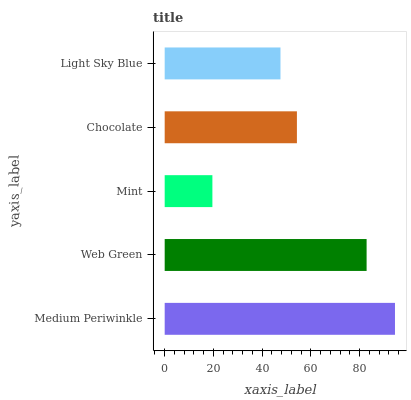Is Mint the minimum?
Answer yes or no. Yes. Is Medium Periwinkle the maximum?
Answer yes or no. Yes. Is Web Green the minimum?
Answer yes or no. No. Is Web Green the maximum?
Answer yes or no. No. Is Medium Periwinkle greater than Web Green?
Answer yes or no. Yes. Is Web Green less than Medium Periwinkle?
Answer yes or no. Yes. Is Web Green greater than Medium Periwinkle?
Answer yes or no. No. Is Medium Periwinkle less than Web Green?
Answer yes or no. No. Is Chocolate the high median?
Answer yes or no. Yes. Is Chocolate the low median?
Answer yes or no. Yes. Is Mint the high median?
Answer yes or no. No. Is Web Green the low median?
Answer yes or no. No. 